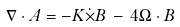Convert formula to latex. <formula><loc_0><loc_0><loc_500><loc_500>\nabla \cdot A = - K \dot { \times } B \, - \, 4 \Omega \cdot B</formula> 